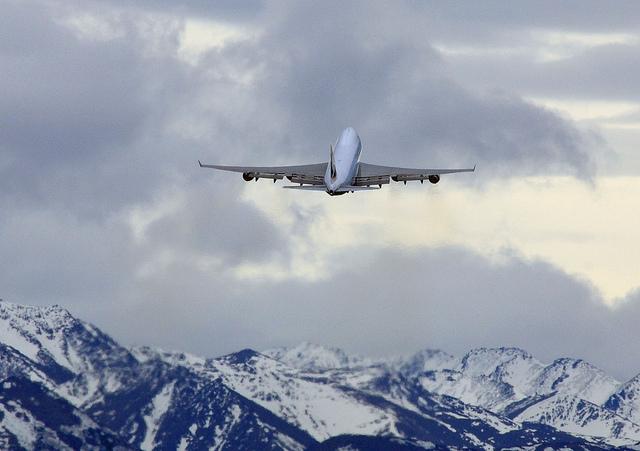Is this an extreme sport?
Answer briefly. No. Is this a clear day?
Quick response, please. No. Is this person attempting a stunt or are they falling?
Answer briefly. Flying. What color is the plane?
Give a very brief answer. White. Is the picture an overhead shot?
Be succinct. No. Is this a vacation scene?
Be succinct. No. Is the plane at cruising altitude?
Short answer required. No. What is pictured in the photograph?
Quick response, please. Airplane. What type of clouds are in the sky?
Concise answer only. Gray. Is the plane landing?
Quick response, please. No. What type of plane is this?
Short answer required. Jet. 